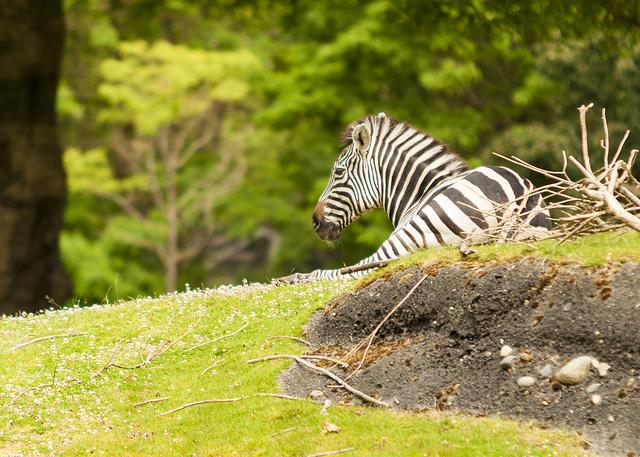Is the zebra resting?
Be succinct. Yes. What is behind the Zebra?
Answer briefly. Tree. What things are in the background?
Be succinct. Trees. Why does this animal have hair?
Be succinct. Warmth. How long is the horse's hair?
Short answer required. Short. 